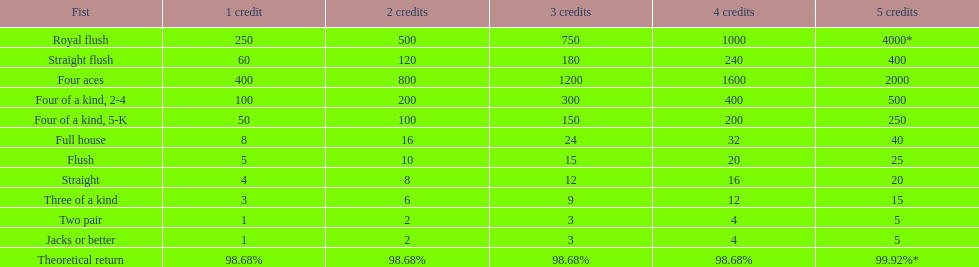Which holds a greater position: a straight or a flush? Flush. 